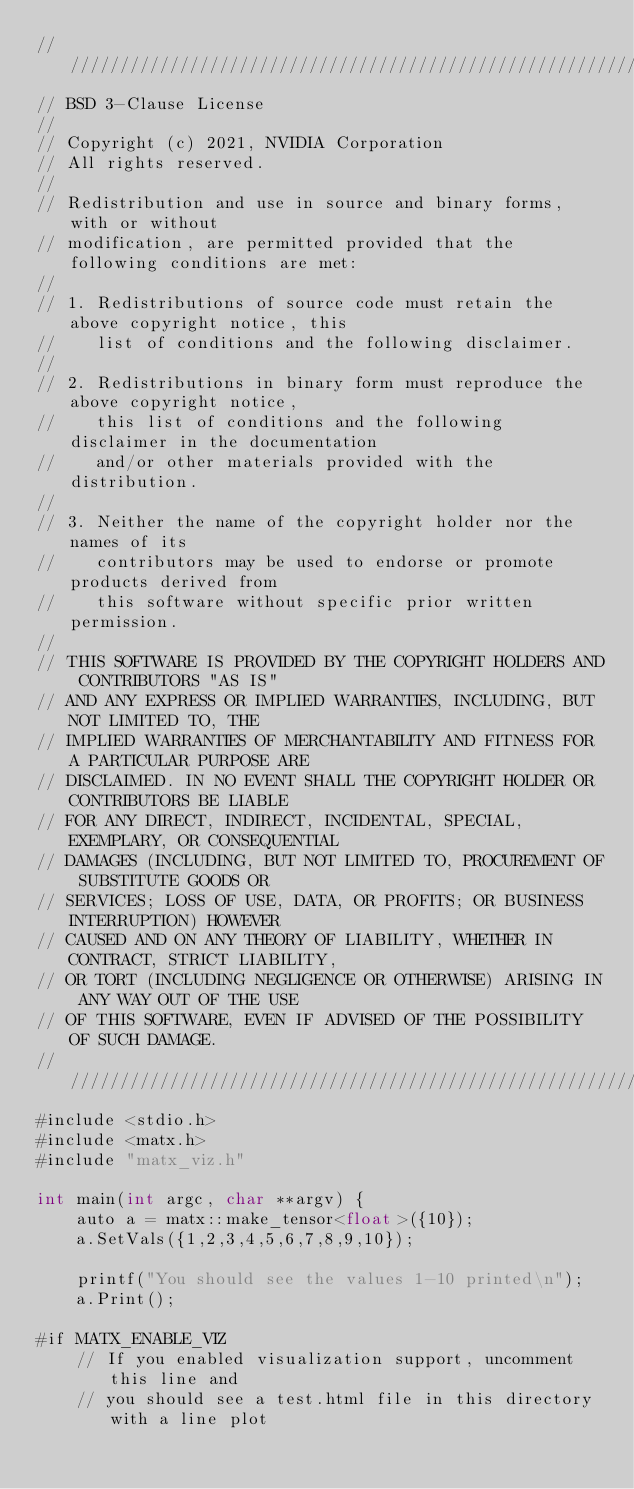Convert code to text. <code><loc_0><loc_0><loc_500><loc_500><_Cuda_>////////////////////////////////////////////////////////////////////////////////
// BSD 3-Clause License
//
// Copyright (c) 2021, NVIDIA Corporation
// All rights reserved.
//
// Redistribution and use in source and binary forms, with or without
// modification, are permitted provided that the following conditions are met:
//
// 1. Redistributions of source code must retain the above copyright notice, this
//    list of conditions and the following disclaimer.
//
// 2. Redistributions in binary form must reproduce the above copyright notice,
//    this list of conditions and the following disclaimer in the documentation
//    and/or other materials provided with the distribution.
//
// 3. Neither the name of the copyright holder nor the names of its
//    contributors may be used to endorse or promote products derived from
//    this software without specific prior written permission.
//
// THIS SOFTWARE IS PROVIDED BY THE COPYRIGHT HOLDERS AND CONTRIBUTORS "AS IS"
// AND ANY EXPRESS OR IMPLIED WARRANTIES, INCLUDING, BUT NOT LIMITED TO, THE
// IMPLIED WARRANTIES OF MERCHANTABILITY AND FITNESS FOR A PARTICULAR PURPOSE ARE
// DISCLAIMED. IN NO EVENT SHALL THE COPYRIGHT HOLDER OR CONTRIBUTORS BE LIABLE
// FOR ANY DIRECT, INDIRECT, INCIDENTAL, SPECIAL, EXEMPLARY, OR CONSEQUENTIAL
// DAMAGES (INCLUDING, BUT NOT LIMITED TO, PROCUREMENT OF SUBSTITUTE GOODS OR
// SERVICES; LOSS OF USE, DATA, OR PROFITS; OR BUSINESS INTERRUPTION) HOWEVER
// CAUSED AND ON ANY THEORY OF LIABILITY, WHETHER IN CONTRACT, STRICT LIABILITY,
// OR TORT (INCLUDING NEGLIGENCE OR OTHERWISE) ARISING IN ANY WAY OUT OF THE USE
// OF THIS SOFTWARE, EVEN IF ADVISED OF THE POSSIBILITY OF SUCH DAMAGE.
/////////////////////////////////////////////////////////////////////////////////
#include <stdio.h>
#include <matx.h>
#include "matx_viz.h"

int main(int argc, char **argv) {
    auto a = matx::make_tensor<float>({10});
    a.SetVals({1,2,3,4,5,6,7,8,9,10});

    printf("You should see the values 1-10 printed\n");
    a.Print();

#if MATX_ENABLE_VIZ
    // If you enabled visualization support, uncomment this line and
    // you should see a test.html file in this directory with a line plot</code> 